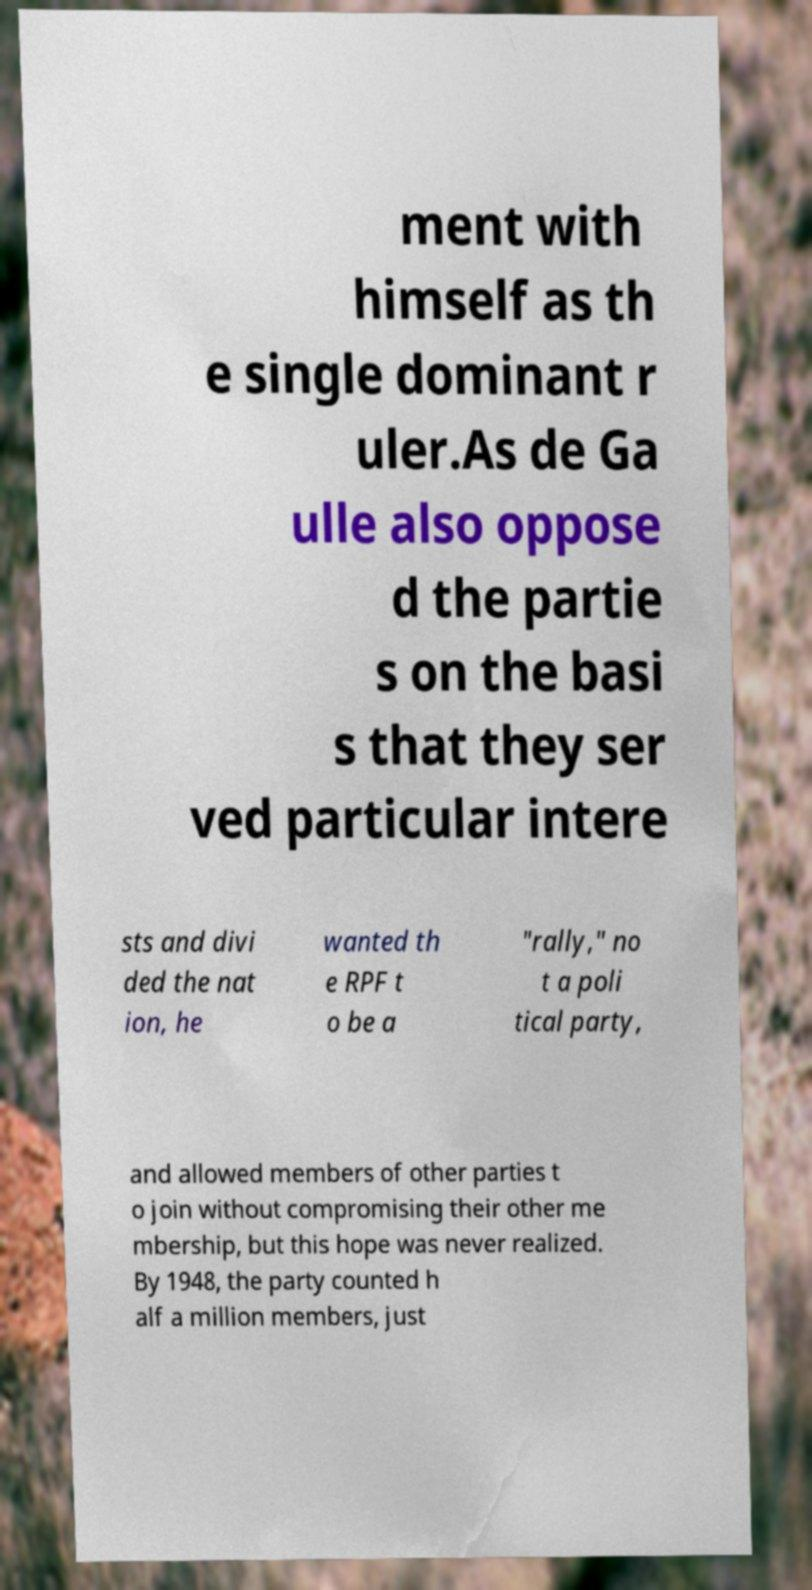There's text embedded in this image that I need extracted. Can you transcribe it verbatim? ment with himself as th e single dominant r uler.As de Ga ulle also oppose d the partie s on the basi s that they ser ved particular intere sts and divi ded the nat ion, he wanted th e RPF t o be a "rally," no t a poli tical party, and allowed members of other parties t o join without compromising their other me mbership, but this hope was never realized. By 1948, the party counted h alf a million members, just 